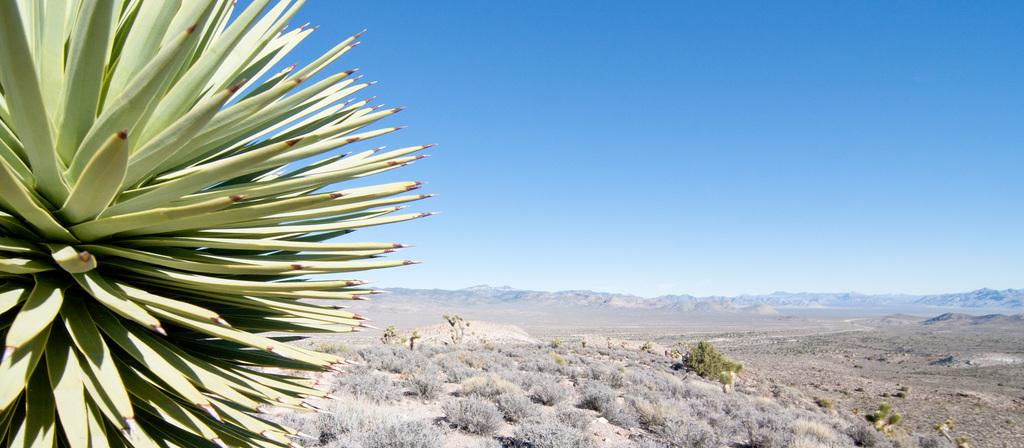What type of vegetation is present on the ground in the image? There are trees on the ground in the image. What type of natural formation can be seen in the background of the image? There are mountains visible in the background of the image. What else is visible in the background of the image besides the mountains? The sky is visible in the background of the image. Can you tell me how many actors are standing on the pipe in the image? There are no actors or pipes present in the image. What type of grass is growing on the trees in the image? There is no grass growing on the trees in the image; it is a tree with leaves. 